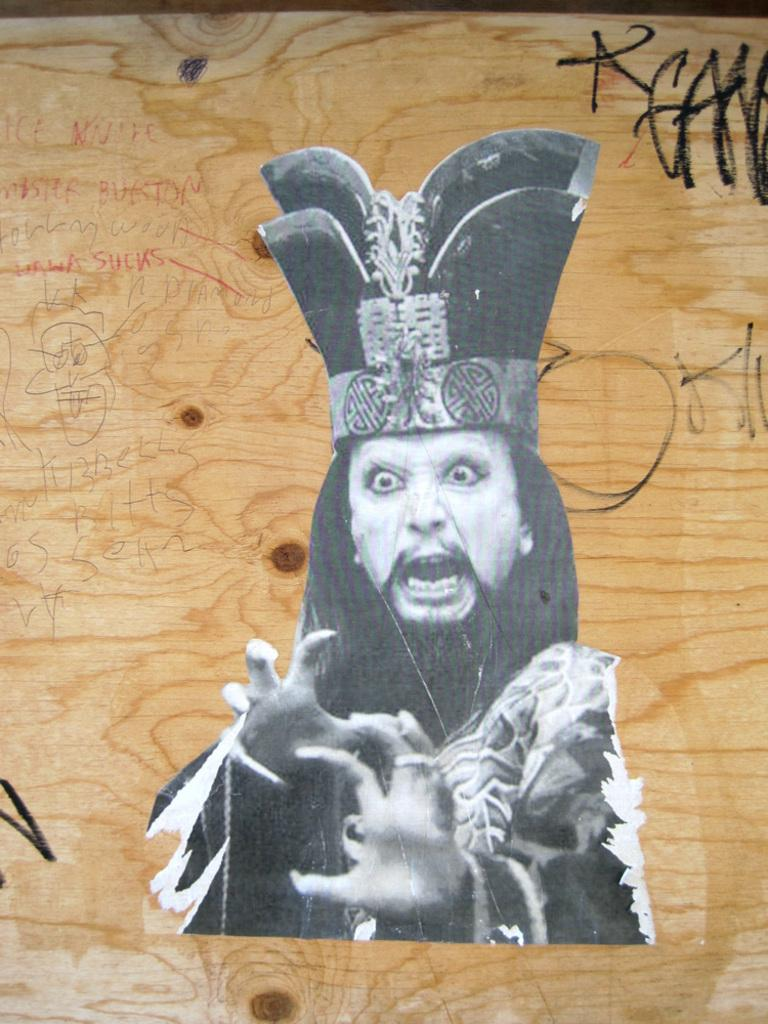What type of object is present in the image that resembles a sticker? There is a human sticker in the image. What is the surface on which the text is written in the image? The text is written on a wooden surface in the image. Can you tell me how many goats are visible in the image? There are no goats present in the image. What type of vehicle is parked next to the wooden surface in the image? There is no vehicle present in the image. 